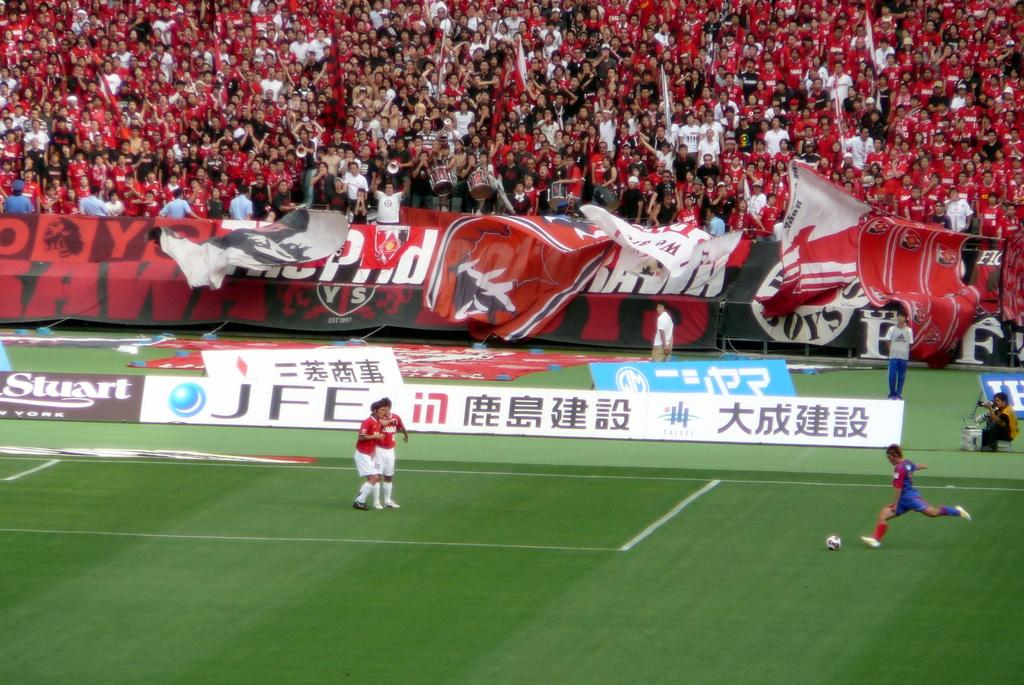Provide a one-sentence caption for the provided image. A soccer field with players playing a game in front of a stand full of fans with banners with Chinese writing in front of the stands. 